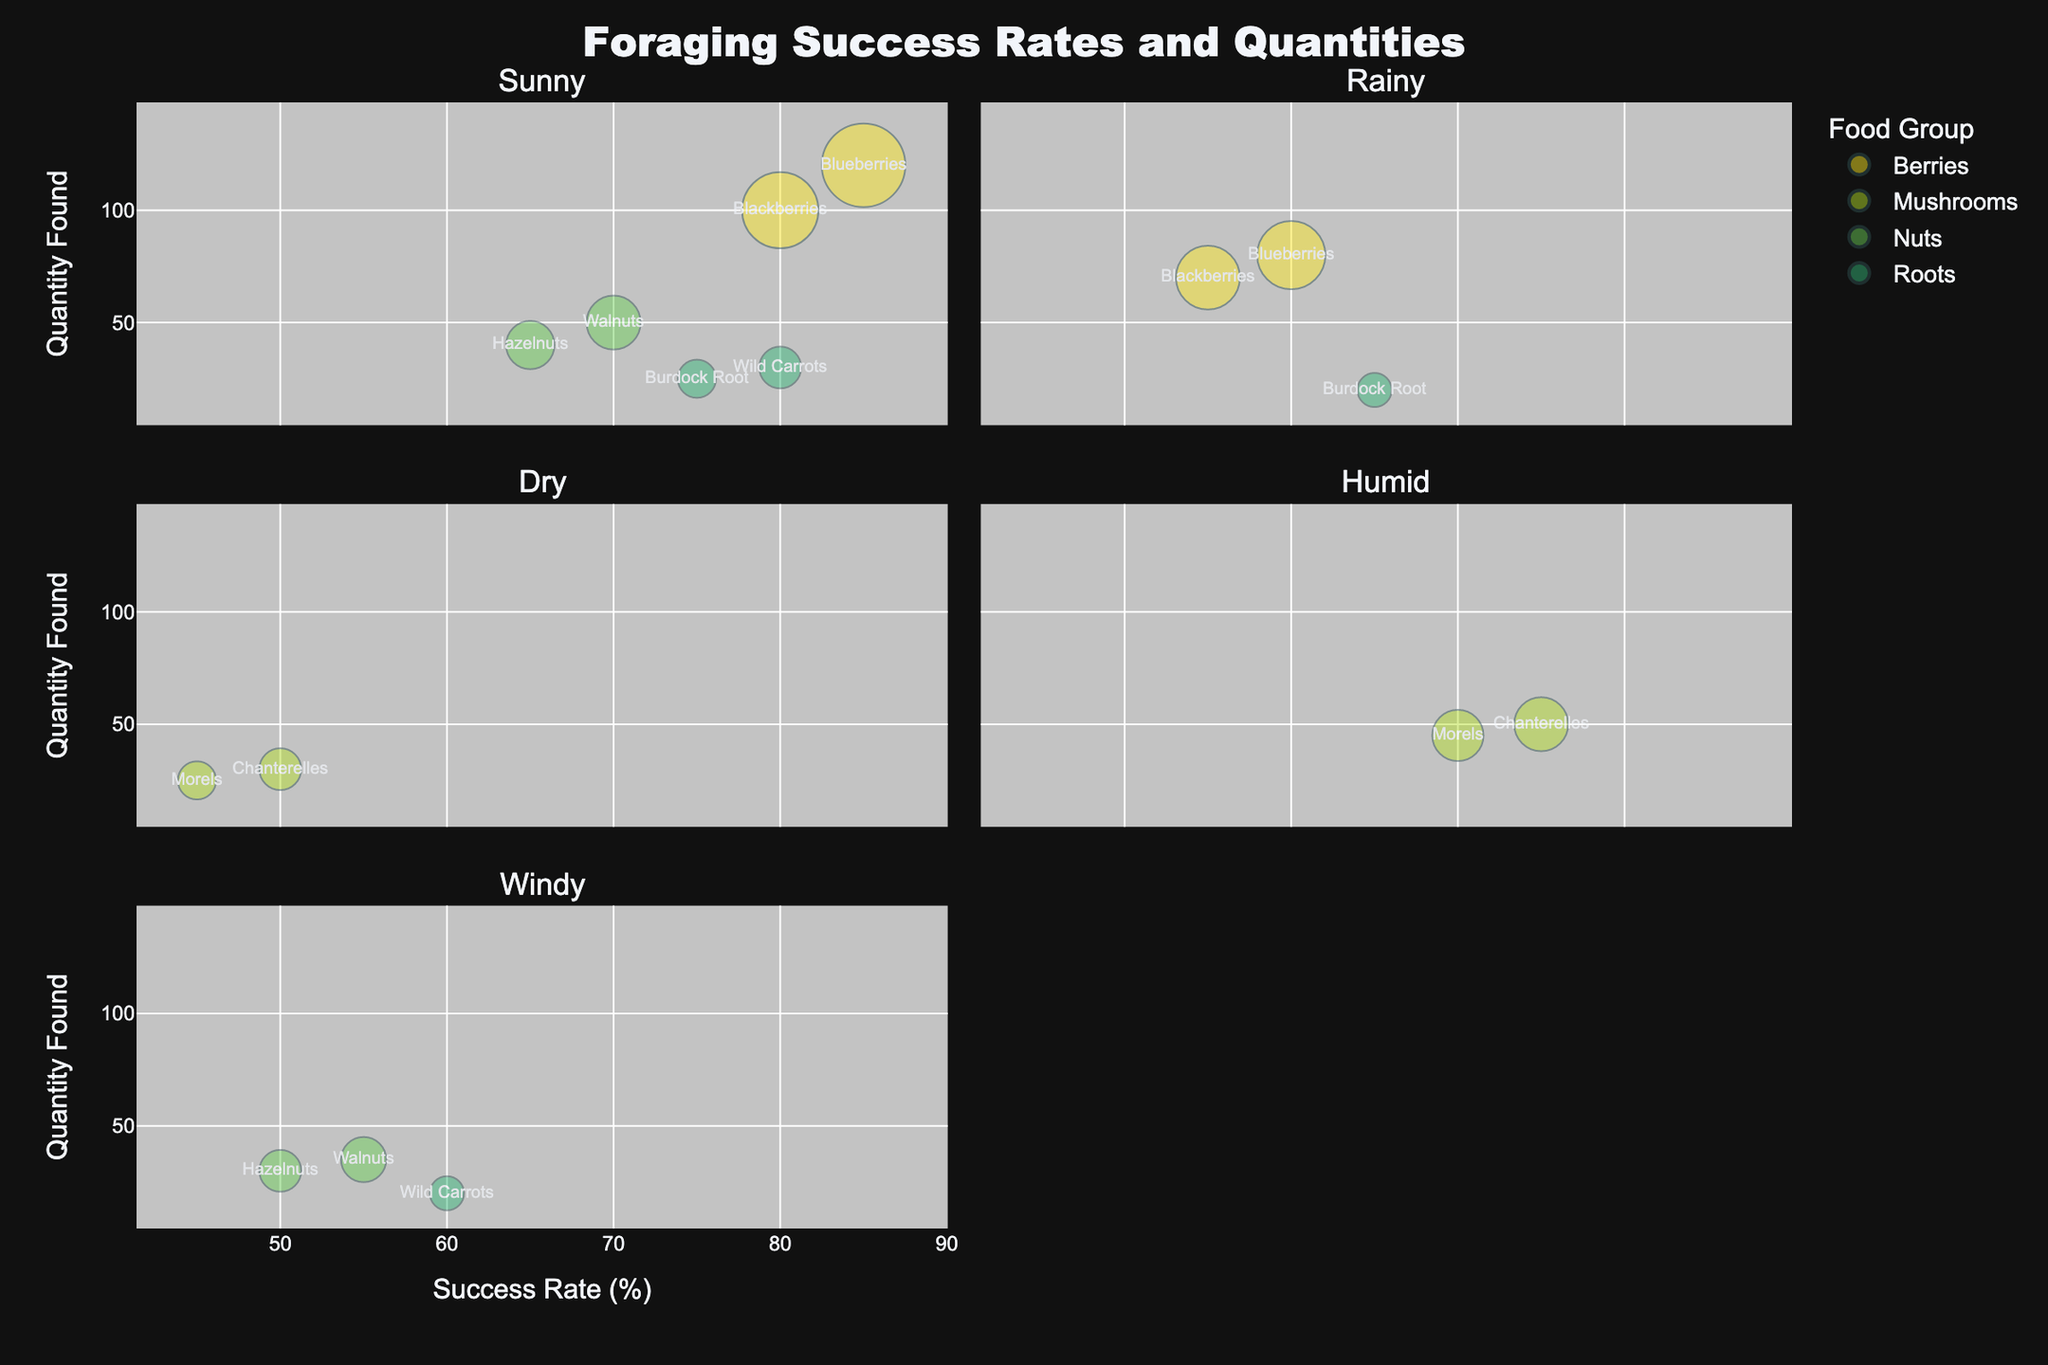How many food groups are represented in the chart? Count the distinct colors representing different food groups. There are four colors, each indicating a unique food group.
Answer: Four Which food group has the highest success rate under sunny weather? Look for the bubble with the highest "Success Rate (%)" value under the sunny weather facet. Blueberries (85%) has the highest success rate.
Answer: Berries (Blueberries) What is the total quantity of Morels found in dry and humid weather conditions? Sum the "Quantity Found" values for Morels under both weather conditions: 25 (dry) + 45 (humid) = 70.
Answer: 70 Compare the success rate of Blackberries in sunny and rainy weather. Which is higher and by how much? Identify the success rates of Blackberries in sunny (80%) and rainy (55%) weather. The difference is 80% - 55% = 25%.
Answer: Sunny, by 25% What is the smallest quantity found among all food items? Find the smallest "Quantity Found" value across all data points. Chanterelles (Dry) has a quantity of 25, which is the smallest.
Answer: 25 Which food group shows the largest quantity variation between two weather conditions? Calculate the difference in quantities found for each food under different weather conditions. Morels show the largest difference: 45 (Humid) - 25 (Dry) = 20.
Answer: Mushrooms (Morels) Which weather condition shows the highest average success rate for mushrooms? Calculate the average success rate for mushrooms under Dry (50%+45%)/2 = 47.5% and Humid (75%+70%)/2 = 72.5%.
Answer: Humid Are there any food items that have the same success rate under different weather conditions? Check and compare the success rates of each food item individually. There are no repeated success rates under different conditions.
Answer: No For the food group "Roots", what is the average success rate across all weather conditions? Average the success rates of Wild Carrots (80%+60%) and Burdock Root (75%+65%). (80%+60%+75%+65%)/4 = 70%.
Answer: 70% Describe the trend of success rates for nuts under different weather conditions. Observe how success rates for Walnuts (70% under Sunny, 55% under Windy) and Hazelnuts (65% under Sunny, 50% under Windy) decrease under windy conditions.
Answer: Decrease 